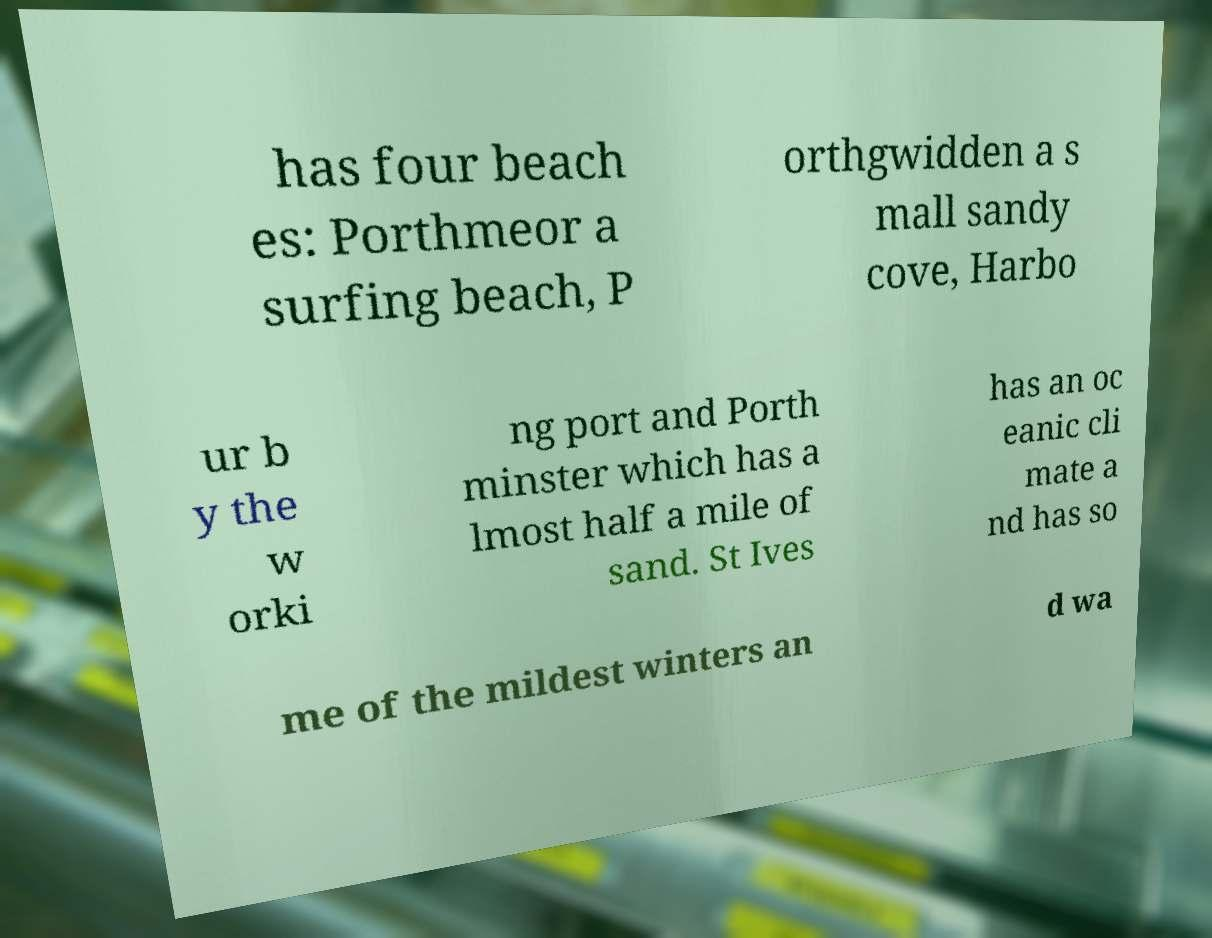Please read and relay the text visible in this image. What does it say? has four beach es: Porthmeor a surfing beach, P orthgwidden a s mall sandy cove, Harbo ur b y the w orki ng port and Porth minster which has a lmost half a mile of sand. St Ives has an oc eanic cli mate a nd has so me of the mildest winters an d wa 